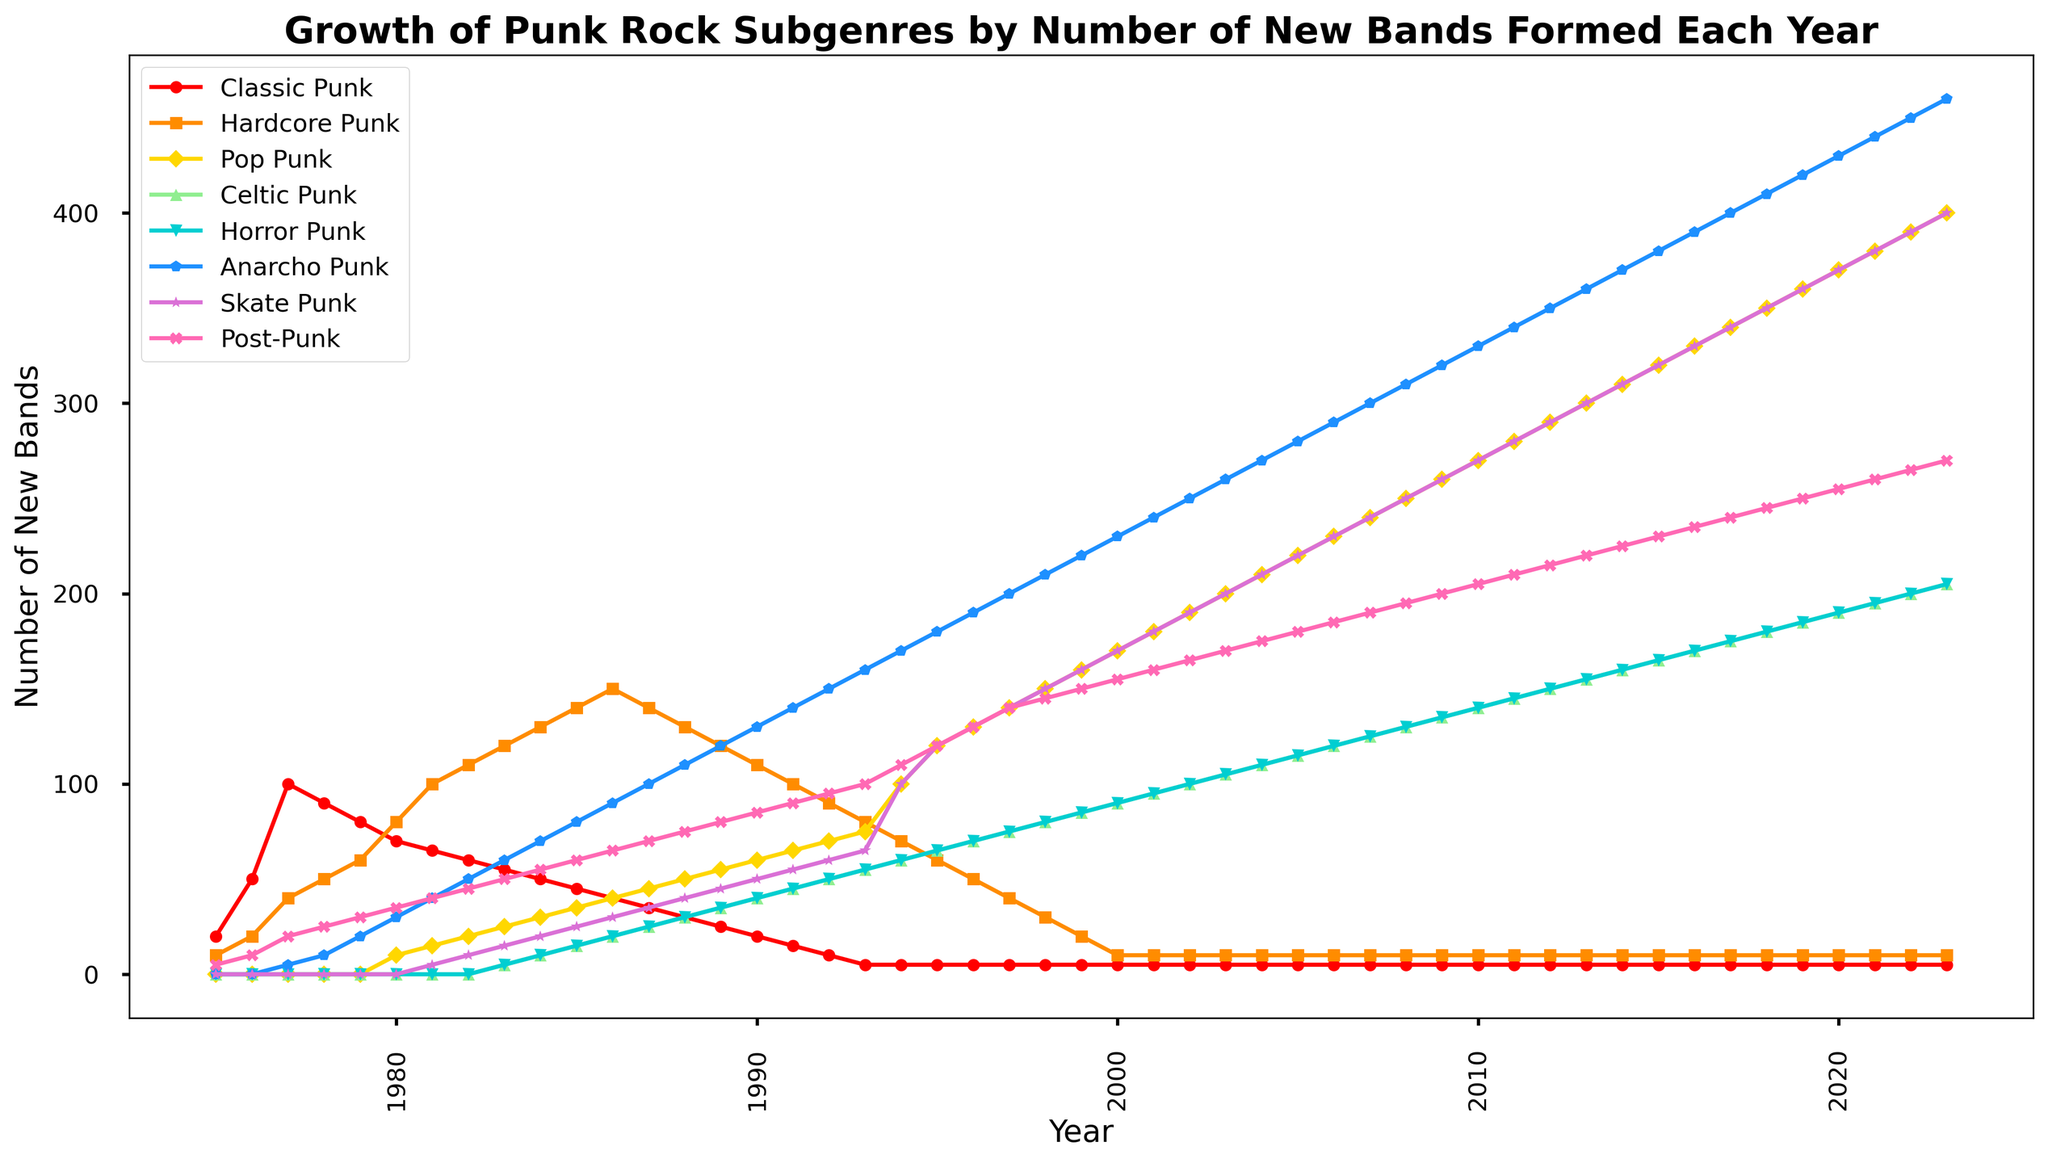Which subgenre had the largest number of new bands formed in 2023? From the chart, check the height of each line at the year 2023. The subgenre with the highest point on the Y-axis is the one with the largest number of new bands.
Answer: Anarcho Punk When did Pop Punk start seeing significant growth? Look at the Pop Punk line and identify the year when it starts noticeably increasing. This is marked by a sharp upward trend.
Answer: 1994 Compare the number of new Hardcore Punk and Post-Punk bands in 1980. Which had more new bands? For 1980, observe the points on both the Hardcore Punk and Post-Punk lines. Compare their Y-axis values.
Answer: Post-Punk By how much did the number of new Celtic Punk bands increase from 1995 to 2000? Find the number of new Celtic Punk bands in 1995 and 2000 and subtract the former from the latter.
Answer: 25 Was there a decrease in the number of new Classic Punk bands from 1977 to 1983? Check the Classic Punk line between the years 1977 and 1983. If the line descends, it indicates a decrease.
Answer: Yes Which subgenre saw a relatively steady growth starting from 1977 to 2023? Identify the subgenre with a consistently upward trend without steep drops between 1977 and 2023.
Answer: Anarcho Punk How did the trend for Skate Punk change between 2000 and 2010? Observe the Skate Punk line between 2000 and 2010 and describe how it moves (increases, decreases, or remains steady).
Answer: Increased 